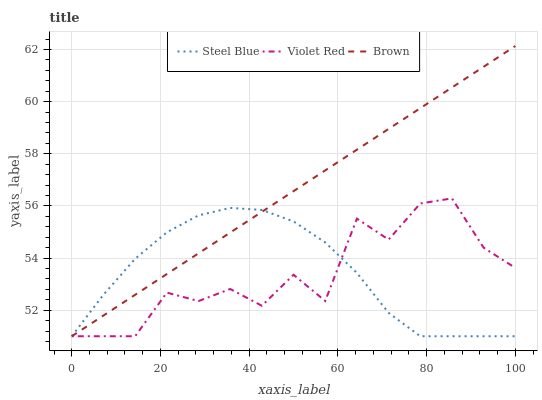Does Violet Red have the minimum area under the curve?
Answer yes or no. Yes. Does Brown have the maximum area under the curve?
Answer yes or no. Yes. Does Steel Blue have the minimum area under the curve?
Answer yes or no. No. Does Steel Blue have the maximum area under the curve?
Answer yes or no. No. Is Brown the smoothest?
Answer yes or no. Yes. Is Violet Red the roughest?
Answer yes or no. Yes. Is Steel Blue the smoothest?
Answer yes or no. No. Is Steel Blue the roughest?
Answer yes or no. No. Does Brown have the lowest value?
Answer yes or no. Yes. Does Brown have the highest value?
Answer yes or no. Yes. Does Violet Red have the highest value?
Answer yes or no. No. Does Brown intersect Violet Red?
Answer yes or no. Yes. Is Brown less than Violet Red?
Answer yes or no. No. Is Brown greater than Violet Red?
Answer yes or no. No. 